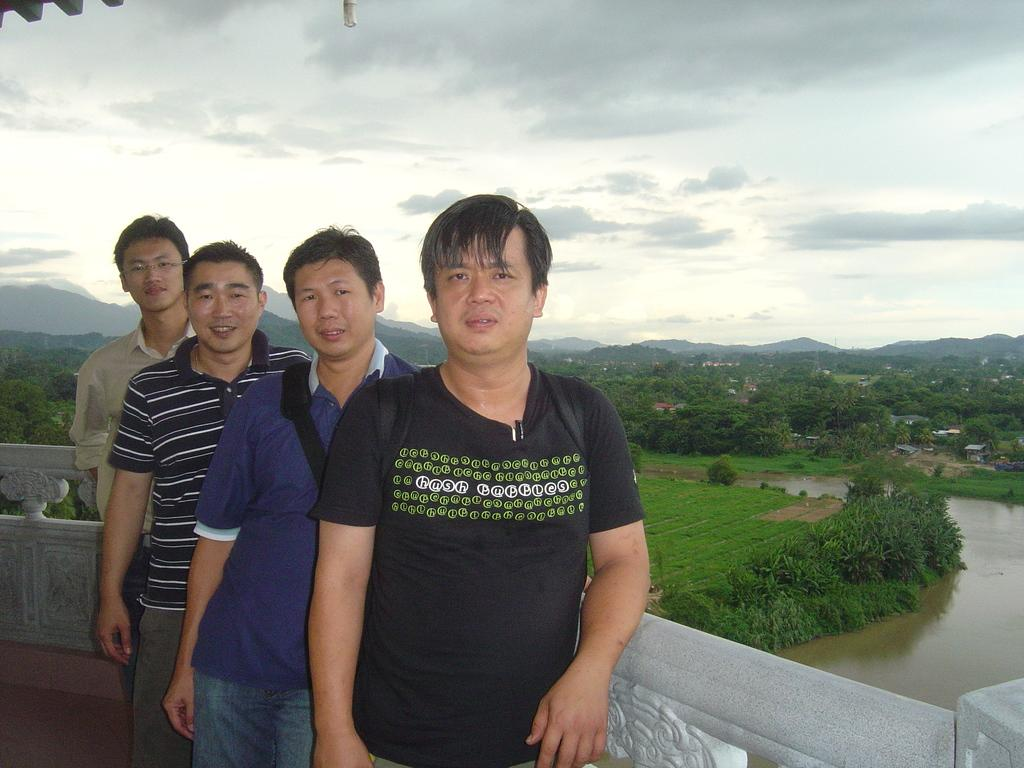How many people are present in the image? There are four persons standing in the image. What is visible in the image besides the people? Water, buildings, trees, hills, and the sky are visible in the image. Can you describe the natural features in the image? There are trees and hills visible in the image. What is the background of the image? The sky is visible in the background of the image. What type of division is being performed by the person holding a hammer in the image? There is no person holding a hammer in the image, and therefore no division is being performed. Can you tell me which wrist is being used to hold the wristwatch in the image? There is no wristwatch present in the image. 